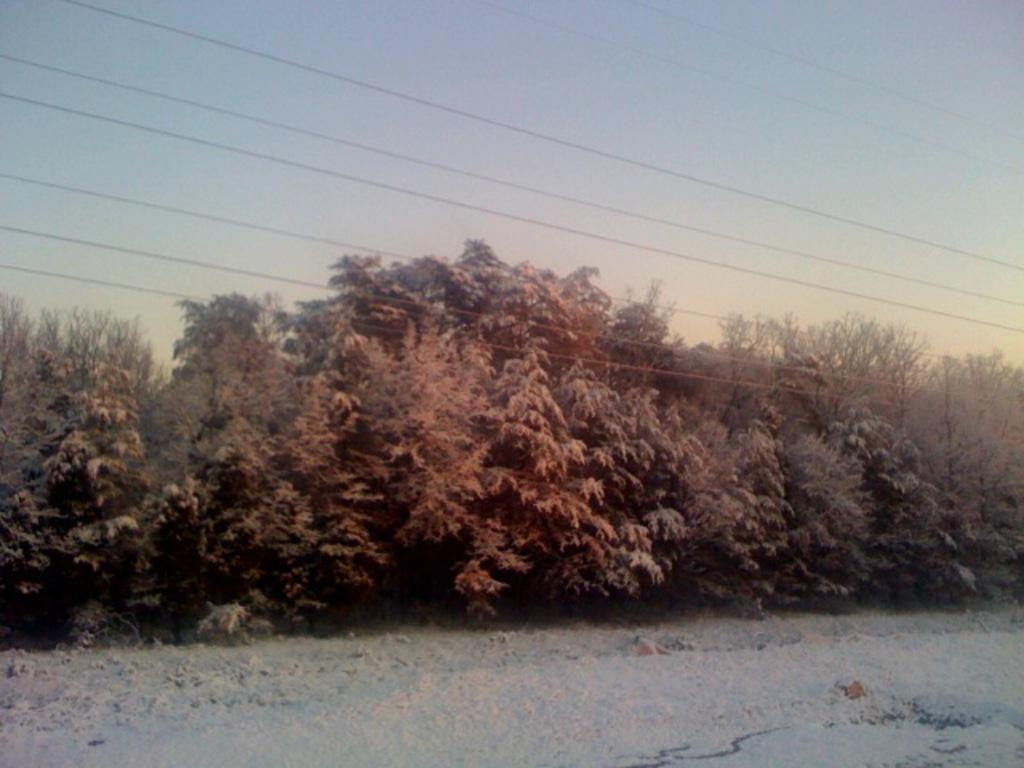What type of weather is depicted in the image? The image shows snow at the bottom, indicating cold weather. What type of vegetation can be seen in the image? There are green trees in the middle of the image. What else is visible in the image besides the trees and snow? Electric cables are visible in the image. What is visible at the top of the image? The sky is visible at the top of the image. What type of board is being used to fan the trees in the image? There is no board or fan present in the image; it only shows snow, green trees, electric cables, and the sky. 